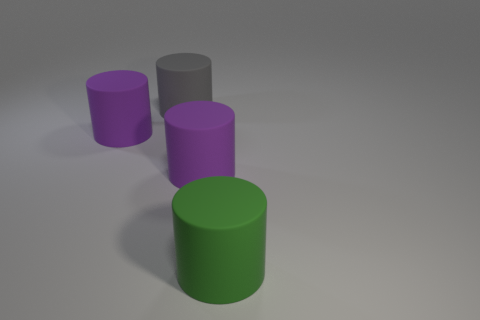Add 3 large green matte cylinders. How many objects exist? 7 Subtract all gray cylinders. How many cylinders are left? 3 Subtract all green cylinders. How many cylinders are left? 3 Subtract 1 cylinders. How many cylinders are left? 3 Subtract all blue cylinders. Subtract all gray balls. How many cylinders are left? 4 Subtract 0 blue balls. How many objects are left? 4 Subtract all green spheres. How many red cylinders are left? 0 Subtract all purple cylinders. Subtract all big gray matte things. How many objects are left? 1 Add 4 green rubber objects. How many green rubber objects are left? 5 Add 3 large brown shiny objects. How many large brown shiny objects exist? 3 